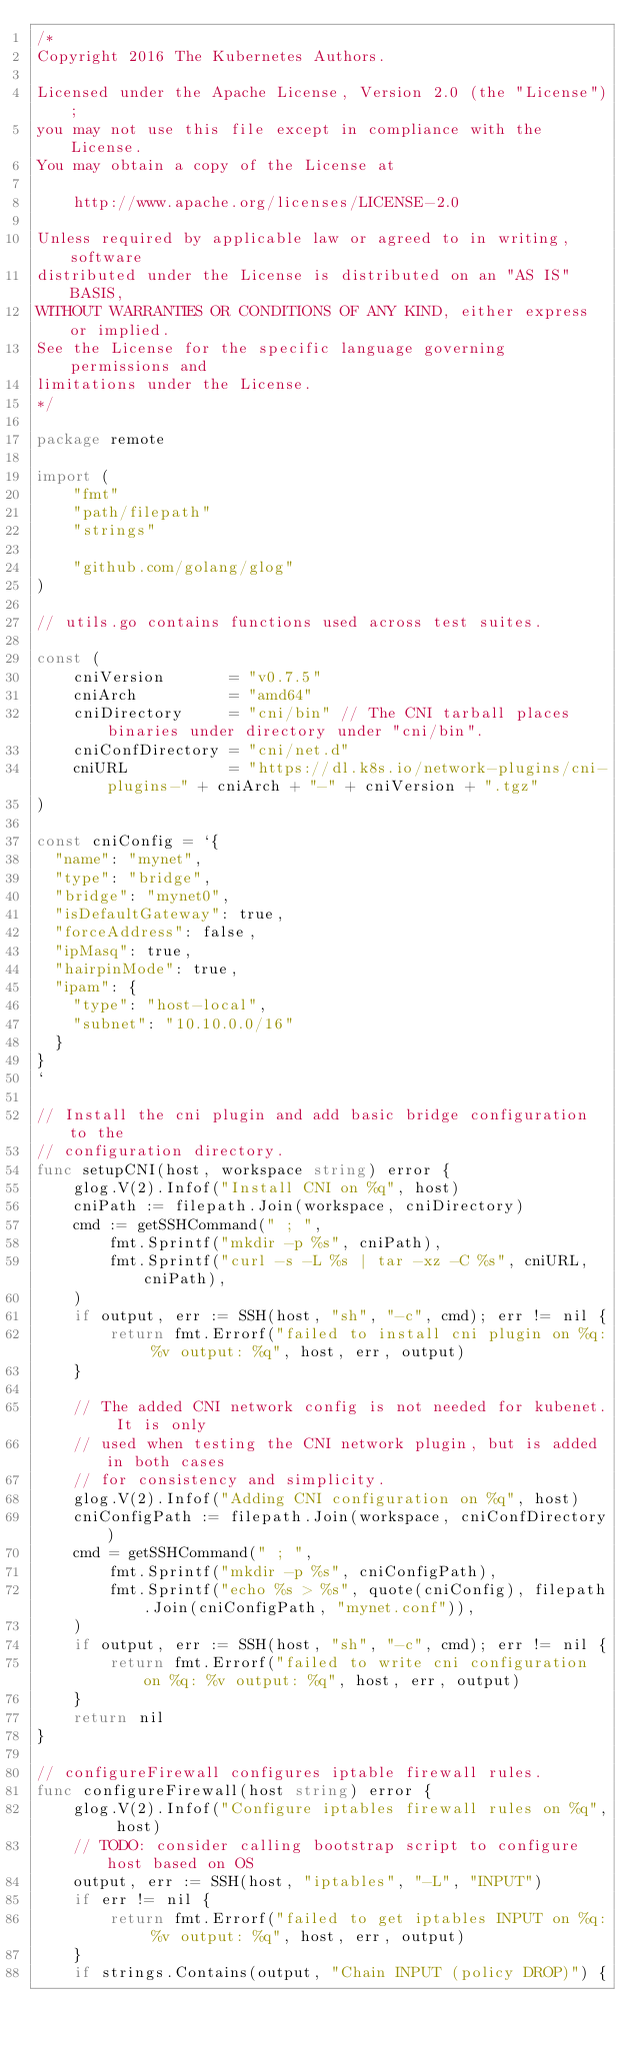Convert code to text. <code><loc_0><loc_0><loc_500><loc_500><_Go_>/*
Copyright 2016 The Kubernetes Authors.

Licensed under the Apache License, Version 2.0 (the "License");
you may not use this file except in compliance with the License.
You may obtain a copy of the License at

    http://www.apache.org/licenses/LICENSE-2.0

Unless required by applicable law or agreed to in writing, software
distributed under the License is distributed on an "AS IS" BASIS,
WITHOUT WARRANTIES OR CONDITIONS OF ANY KIND, either express or implied.
See the License for the specific language governing permissions and
limitations under the License.
*/

package remote

import (
	"fmt"
	"path/filepath"
	"strings"

	"github.com/golang/glog"
)

// utils.go contains functions used across test suites.

const (
	cniVersion       = "v0.7.5"
	cniArch          = "amd64"
	cniDirectory     = "cni/bin" // The CNI tarball places binaries under directory under "cni/bin".
	cniConfDirectory = "cni/net.d"
	cniURL           = "https://dl.k8s.io/network-plugins/cni-plugins-" + cniArch + "-" + cniVersion + ".tgz"
)

const cniConfig = `{
  "name": "mynet",
  "type": "bridge",
  "bridge": "mynet0",
  "isDefaultGateway": true,
  "forceAddress": false,
  "ipMasq": true,
  "hairpinMode": true,
  "ipam": {
    "type": "host-local",
    "subnet": "10.10.0.0/16"
  }
}
`

// Install the cni plugin and add basic bridge configuration to the
// configuration directory.
func setupCNI(host, workspace string) error {
	glog.V(2).Infof("Install CNI on %q", host)
	cniPath := filepath.Join(workspace, cniDirectory)
	cmd := getSSHCommand(" ; ",
		fmt.Sprintf("mkdir -p %s", cniPath),
		fmt.Sprintf("curl -s -L %s | tar -xz -C %s", cniURL, cniPath),
	)
	if output, err := SSH(host, "sh", "-c", cmd); err != nil {
		return fmt.Errorf("failed to install cni plugin on %q: %v output: %q", host, err, output)
	}

	// The added CNI network config is not needed for kubenet. It is only
	// used when testing the CNI network plugin, but is added in both cases
	// for consistency and simplicity.
	glog.V(2).Infof("Adding CNI configuration on %q", host)
	cniConfigPath := filepath.Join(workspace, cniConfDirectory)
	cmd = getSSHCommand(" ; ",
		fmt.Sprintf("mkdir -p %s", cniConfigPath),
		fmt.Sprintf("echo %s > %s", quote(cniConfig), filepath.Join(cniConfigPath, "mynet.conf")),
	)
	if output, err := SSH(host, "sh", "-c", cmd); err != nil {
		return fmt.Errorf("failed to write cni configuration on %q: %v output: %q", host, err, output)
	}
	return nil
}

// configureFirewall configures iptable firewall rules.
func configureFirewall(host string) error {
	glog.V(2).Infof("Configure iptables firewall rules on %q", host)
	// TODO: consider calling bootstrap script to configure host based on OS
	output, err := SSH(host, "iptables", "-L", "INPUT")
	if err != nil {
		return fmt.Errorf("failed to get iptables INPUT on %q: %v output: %q", host, err, output)
	}
	if strings.Contains(output, "Chain INPUT (policy DROP)") {</code> 